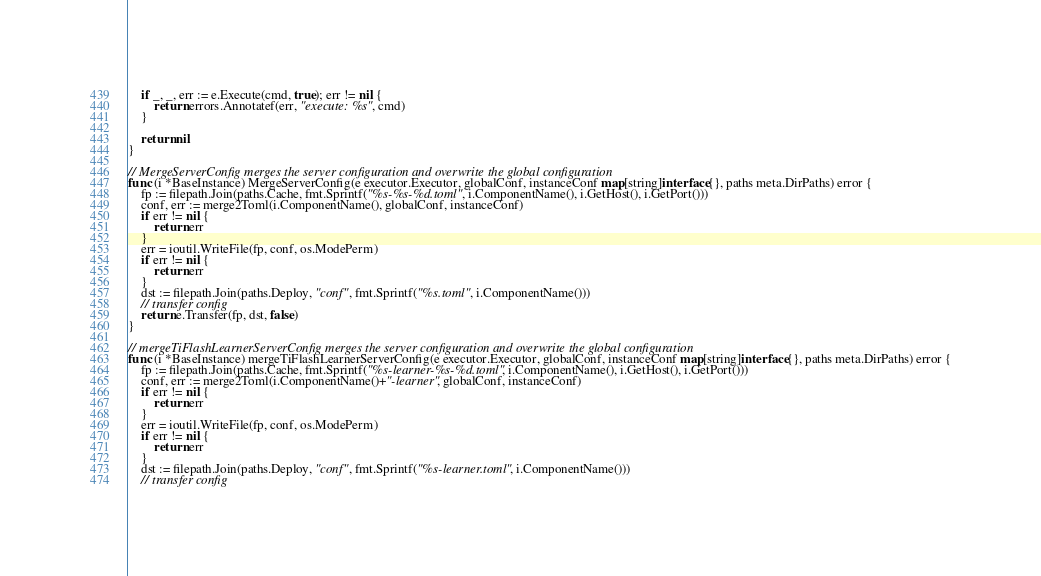Convert code to text. <code><loc_0><loc_0><loc_500><loc_500><_Go_>	if _, _, err := e.Execute(cmd, true); err != nil {
		return errors.Annotatef(err, "execute: %s", cmd)
	}

	return nil
}

// MergeServerConfig merges the server configuration and overwrite the global configuration
func (i *BaseInstance) MergeServerConfig(e executor.Executor, globalConf, instanceConf map[string]interface{}, paths meta.DirPaths) error {
	fp := filepath.Join(paths.Cache, fmt.Sprintf("%s-%s-%d.toml", i.ComponentName(), i.GetHost(), i.GetPort()))
	conf, err := merge2Toml(i.ComponentName(), globalConf, instanceConf)
	if err != nil {
		return err
	}
	err = ioutil.WriteFile(fp, conf, os.ModePerm)
	if err != nil {
		return err
	}
	dst := filepath.Join(paths.Deploy, "conf", fmt.Sprintf("%s.toml", i.ComponentName()))
	// transfer config
	return e.Transfer(fp, dst, false)
}

// mergeTiFlashLearnerServerConfig merges the server configuration and overwrite the global configuration
func (i *BaseInstance) mergeTiFlashLearnerServerConfig(e executor.Executor, globalConf, instanceConf map[string]interface{}, paths meta.DirPaths) error {
	fp := filepath.Join(paths.Cache, fmt.Sprintf("%s-learner-%s-%d.toml", i.ComponentName(), i.GetHost(), i.GetPort()))
	conf, err := merge2Toml(i.ComponentName()+"-learner", globalConf, instanceConf)
	if err != nil {
		return err
	}
	err = ioutil.WriteFile(fp, conf, os.ModePerm)
	if err != nil {
		return err
	}
	dst := filepath.Join(paths.Deploy, "conf", fmt.Sprintf("%s-learner.toml", i.ComponentName()))
	// transfer config</code> 